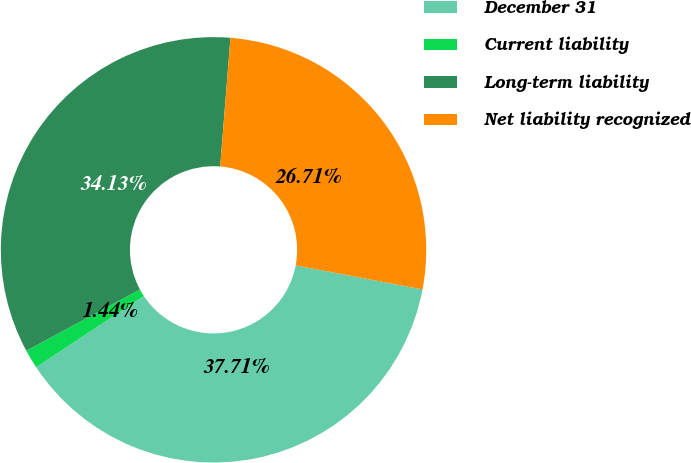<chart> <loc_0><loc_0><loc_500><loc_500><pie_chart><fcel>December 31<fcel>Current liability<fcel>Long-term liability<fcel>Net liability recognized<nl><fcel>37.71%<fcel>1.44%<fcel>34.13%<fcel>26.71%<nl></chart> 